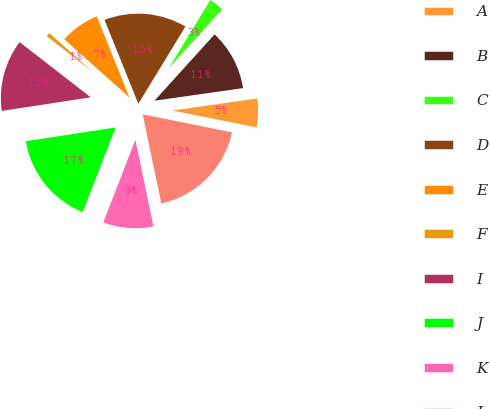<chart> <loc_0><loc_0><loc_500><loc_500><pie_chart><fcel>A<fcel>B<fcel>C<fcel>D<fcel>E<fcel>F<fcel>I<fcel>J<fcel>K<fcel>L<nl><fcel>5.4%<fcel>11.04%<fcel>3.0%<fcel>14.81%<fcel>7.28%<fcel>1.12%<fcel>12.93%<fcel>16.69%<fcel>9.16%<fcel>18.57%<nl></chart> 